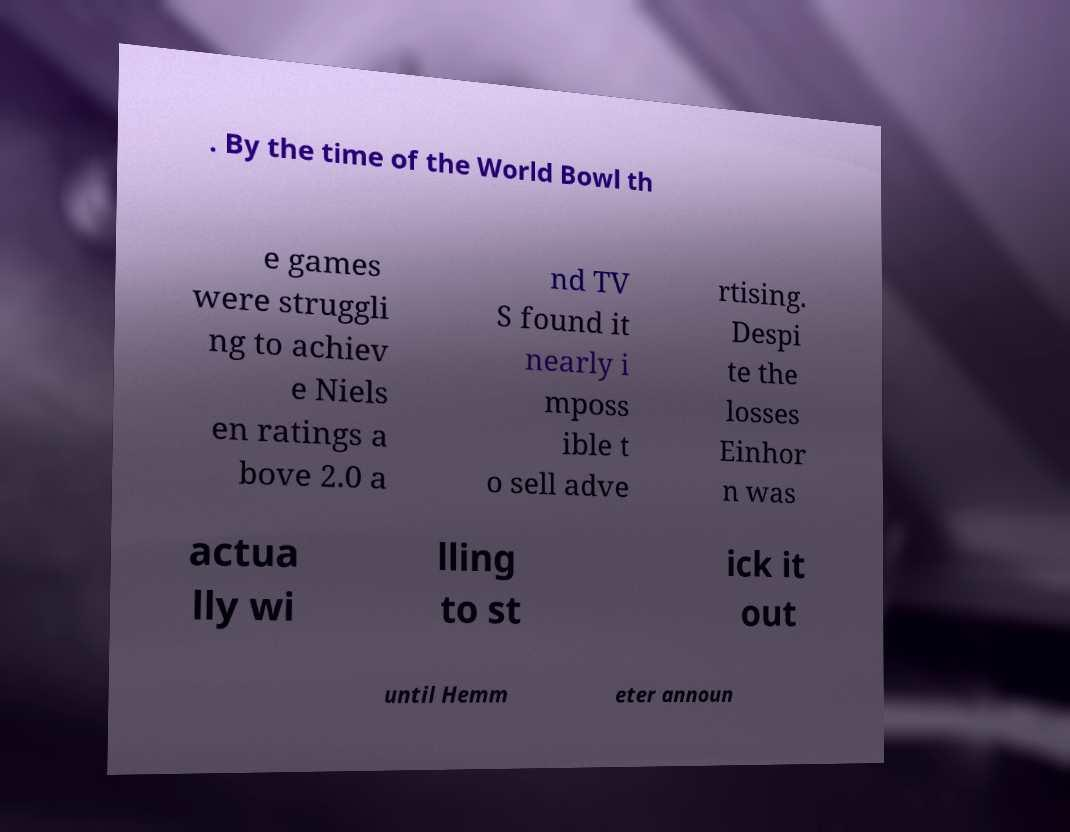I need the written content from this picture converted into text. Can you do that? . By the time of the World Bowl th e games were struggli ng to achiev e Niels en ratings a bove 2.0 a nd TV S found it nearly i mposs ible t o sell adve rtising. Despi te the losses Einhor n was actua lly wi lling to st ick it out until Hemm eter announ 